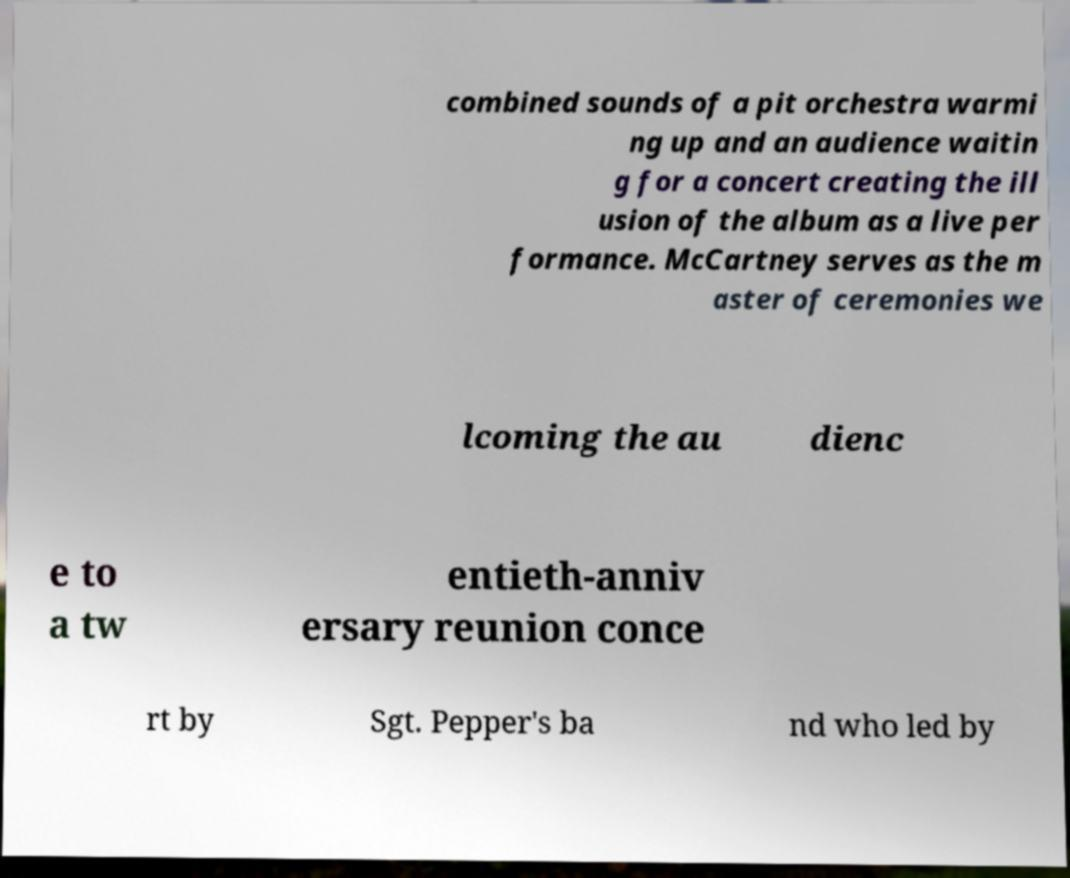Please read and relay the text visible in this image. What does it say? combined sounds of a pit orchestra warmi ng up and an audience waitin g for a concert creating the ill usion of the album as a live per formance. McCartney serves as the m aster of ceremonies we lcoming the au dienc e to a tw entieth-anniv ersary reunion conce rt by Sgt. Pepper's ba nd who led by 